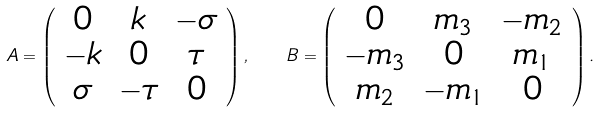Convert formula to latex. <formula><loc_0><loc_0><loc_500><loc_500>A = \left ( \begin{array} { c c c } 0 & k & - \sigma \\ - k & 0 & \tau \\ \sigma & - \tau & 0 \end{array} \right ) , \quad B = \left ( \begin{array} { c c c } 0 & m _ { 3 } & - m _ { 2 } \\ - m _ { 3 } & 0 & m _ { 1 } \\ m _ { 2 } & - m _ { 1 } & 0 \end{array} \right ) .</formula> 